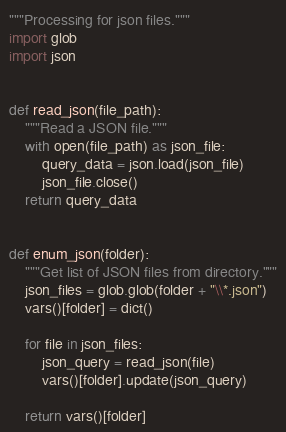<code> <loc_0><loc_0><loc_500><loc_500><_Python_>"""Processing for json files."""
import glob
import json


def read_json(file_path):
    """Read a JSON file."""
    with open(file_path) as json_file:
        query_data = json.load(json_file)
        json_file.close()
    return query_data


def enum_json(folder):
    """Get list of JSON files from directory."""
    json_files = glob.glob(folder + "\\*.json")
    vars()[folder] = dict()

    for file in json_files:
        json_query = read_json(file)
        vars()[folder].update(json_query)

    return vars()[folder]
</code> 